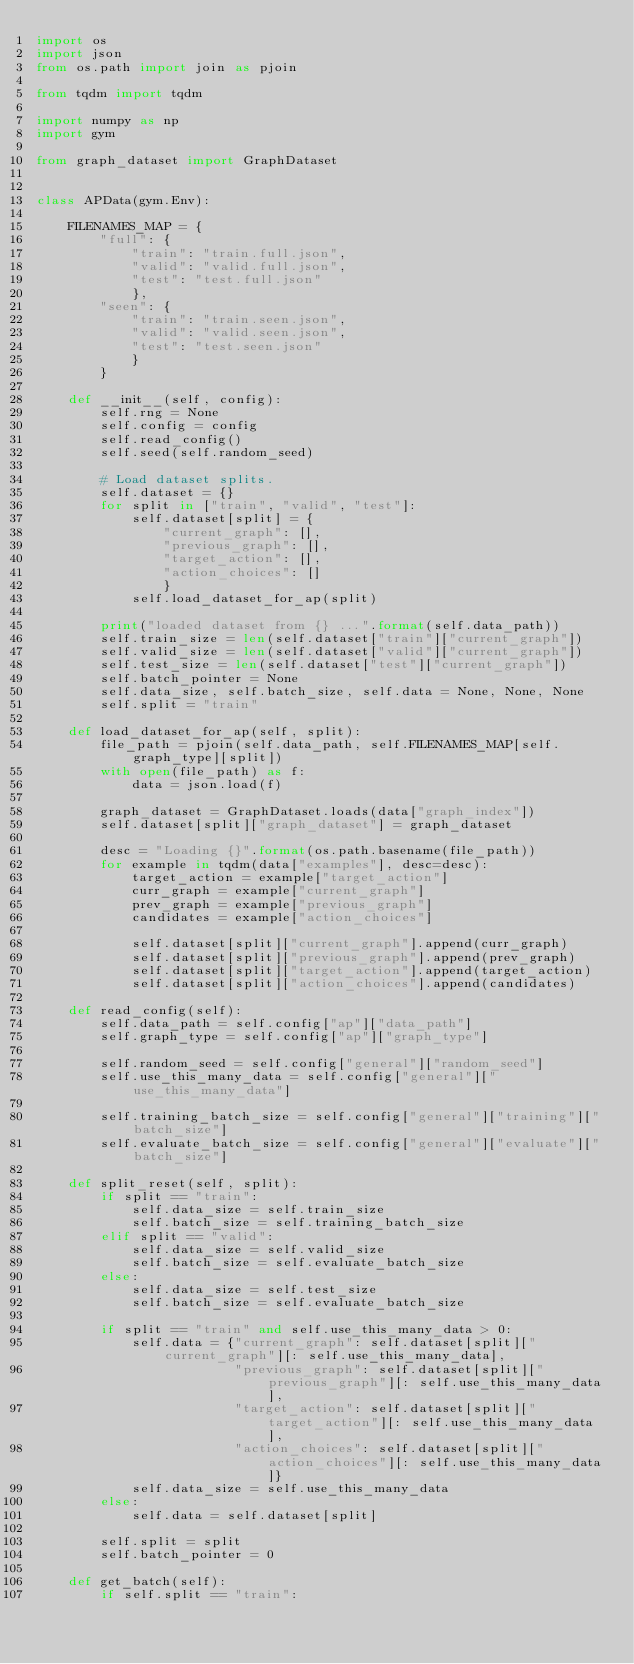<code> <loc_0><loc_0><loc_500><loc_500><_Python_>import os
import json
from os.path import join as pjoin

from tqdm import tqdm

import numpy as np
import gym

from graph_dataset import GraphDataset


class APData(gym.Env):

    FILENAMES_MAP = {
        "full": {
            "train": "train.full.json",
            "valid": "valid.full.json",
            "test": "test.full.json"
            },
        "seen": {
            "train": "train.seen.json",
            "valid": "valid.seen.json",
            "test": "test.seen.json"
            }
        }

    def __init__(self, config):
        self.rng = None
        self.config = config
        self.read_config()
        self.seed(self.random_seed)

        # Load dataset splits.
        self.dataset = {}
        for split in ["train", "valid", "test"]:
            self.dataset[split] = {
                "current_graph": [],
                "previous_graph": [],
                "target_action": [],
                "action_choices": []
                }
            self.load_dataset_for_ap(split)

        print("loaded dataset from {} ...".format(self.data_path))
        self.train_size = len(self.dataset["train"]["current_graph"])
        self.valid_size = len(self.dataset["valid"]["current_graph"])
        self.test_size = len(self.dataset["test"]["current_graph"])
        self.batch_pointer = None
        self.data_size, self.batch_size, self.data = None, None, None
        self.split = "train"

    def load_dataset_for_ap(self, split):
        file_path = pjoin(self.data_path, self.FILENAMES_MAP[self.graph_type][split])
        with open(file_path) as f:
            data = json.load(f)

        graph_dataset = GraphDataset.loads(data["graph_index"])
        self.dataset[split]["graph_dataset"] = graph_dataset

        desc = "Loading {}".format(os.path.basename(file_path))
        for example in tqdm(data["examples"], desc=desc):
            target_action = example["target_action"]
            curr_graph = example["current_graph"]
            prev_graph = example["previous_graph"]
            candidates = example["action_choices"]

            self.dataset[split]["current_graph"].append(curr_graph)
            self.dataset[split]["previous_graph"].append(prev_graph)
            self.dataset[split]["target_action"].append(target_action)
            self.dataset[split]["action_choices"].append(candidates)

    def read_config(self):
        self.data_path = self.config["ap"]["data_path"]
        self.graph_type = self.config["ap"]["graph_type"]

        self.random_seed = self.config["general"]["random_seed"]
        self.use_this_many_data = self.config["general"]["use_this_many_data"]

        self.training_batch_size = self.config["general"]["training"]["batch_size"]
        self.evaluate_batch_size = self.config["general"]["evaluate"]["batch_size"]

    def split_reset(self, split):
        if split == "train":
            self.data_size = self.train_size
            self.batch_size = self.training_batch_size
        elif split == "valid":
            self.data_size = self.valid_size
            self.batch_size = self.evaluate_batch_size
        else:
            self.data_size = self.test_size
            self.batch_size = self.evaluate_batch_size

        if split == "train" and self.use_this_many_data > 0:
            self.data = {"current_graph": self.dataset[split]["current_graph"][: self.use_this_many_data],
                         "previous_graph": self.dataset[split]["previous_graph"][: self.use_this_many_data],
                         "target_action": self.dataset[split]["target_action"][: self.use_this_many_data],
                         "action_choices": self.dataset[split]["action_choices"][: self.use_this_many_data]}
            self.data_size = self.use_this_many_data
        else:
            self.data = self.dataset[split]

        self.split = split
        self.batch_pointer = 0

    def get_batch(self):
        if self.split == "train":</code> 